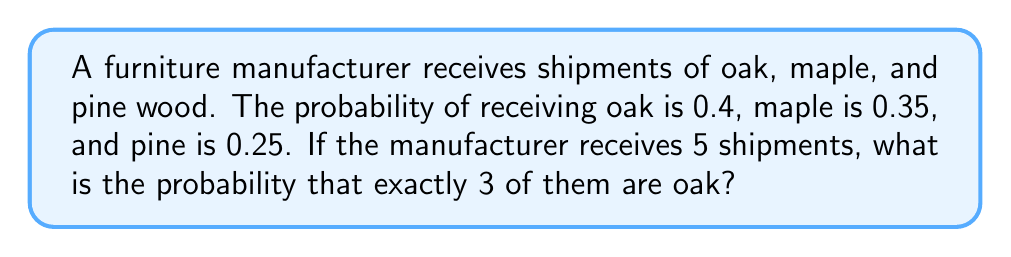Teach me how to tackle this problem. To solve this problem, we can use the binomial probability formula:

$$ P(X = k) = \binom{n}{k} p^k (1-p)^{n-k} $$

Where:
- $n$ is the number of trials (shipments)
- $k$ is the number of successes (oak shipments)
- $p$ is the probability of success (receiving oak)

Given:
- $n = 5$ (total shipments)
- $k = 3$ (desired oak shipments)
- $p = 0.4$ (probability of receiving oak)

Step 1: Calculate the binomial coefficient
$$ \binom{5}{3} = \frac{5!}{3!(5-3)!} = \frac{5 \cdot 4}{2 \cdot 1} = 10 $$

Step 2: Calculate $p^k$
$$ 0.4^3 = 0.064 $$

Step 3: Calculate $(1-p)^{n-k}$
$$ (1-0.4)^{5-3} = 0.6^2 = 0.36 $$

Step 4: Apply the binomial probability formula
$$ P(X = 3) = 10 \cdot 0.064 \cdot 0.36 = 0.2304 $$

Therefore, the probability of receiving exactly 3 oak shipments out of 5 is 0.2304 or 23.04%.
Answer: $0.2304$ 